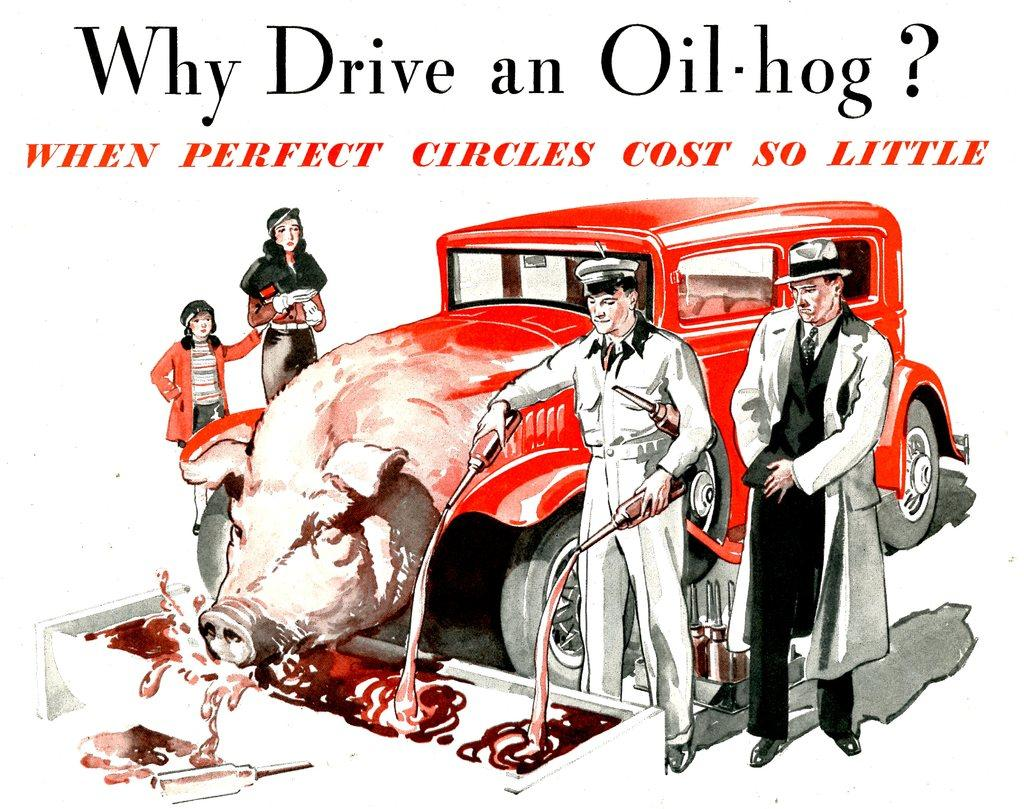What type of image is being described? The image is an animated poster. What can be found in the center of the image? There are people, bottles, a car with a pig's face, and some liquid in the center of the image. What is the car's appearance like in the image? The car has a pig's face in the center of the image. What is present at the top of the image? There is text at the top of the image. Who is the creator of the liquid in the image? There is no information about the creator of the liquid in the image. What do the people in the image believe about the top of the image? The people in the image cannot express their beliefs about the top of the image, as they are part of the image itself. 